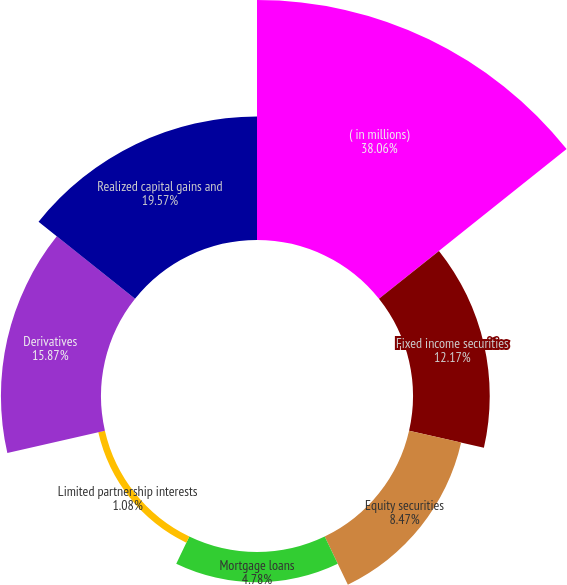Convert chart. <chart><loc_0><loc_0><loc_500><loc_500><pie_chart><fcel>( in millions)<fcel>Fixed income securities<fcel>Equity securities<fcel>Mortgage loans<fcel>Limited partnership interests<fcel>Derivatives<fcel>Realized capital gains and<nl><fcel>38.06%<fcel>12.17%<fcel>8.47%<fcel>4.78%<fcel>1.08%<fcel>15.87%<fcel>19.57%<nl></chart> 